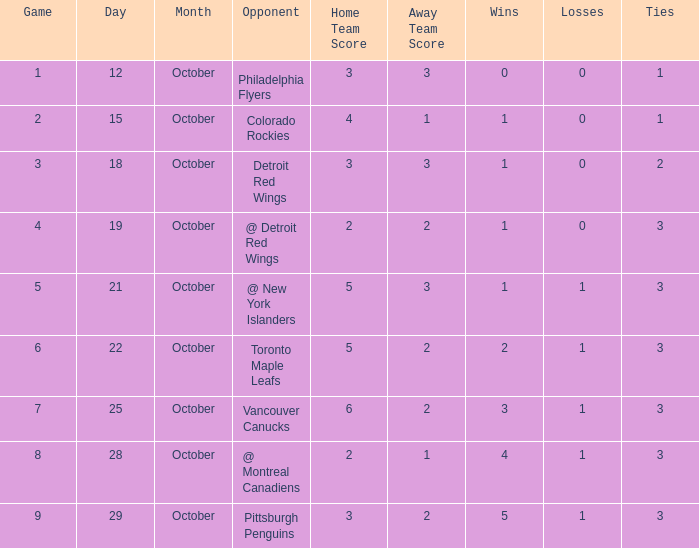What is the best game in october that is less than 1? None. 